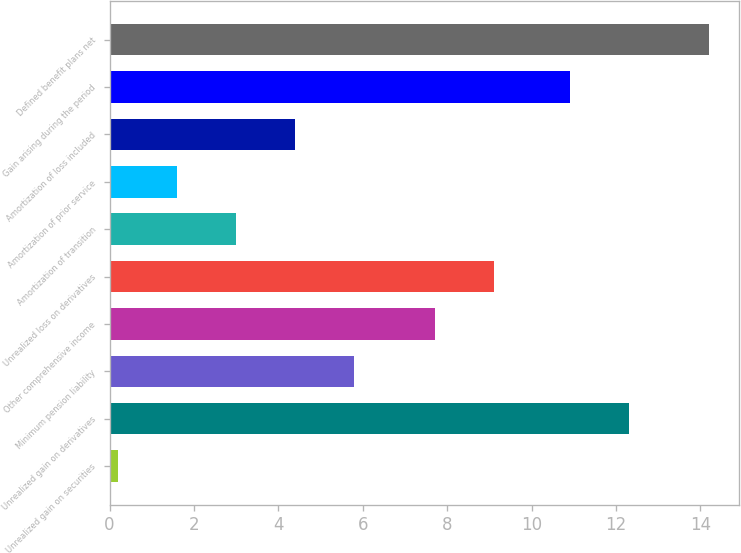<chart> <loc_0><loc_0><loc_500><loc_500><bar_chart><fcel>Unrealized gain on securities<fcel>Unrealized gain on derivatives<fcel>Minimum pension liability<fcel>Other comprehensive income<fcel>Unrealized loss on derivatives<fcel>Amortization of transition<fcel>Amortization of prior service<fcel>Amortization of loss included<fcel>Gain arising during the period<fcel>Defined benefit plans net<nl><fcel>0.2<fcel>12.3<fcel>5.8<fcel>7.7<fcel>9.1<fcel>3<fcel>1.6<fcel>4.4<fcel>10.9<fcel>14.2<nl></chart> 